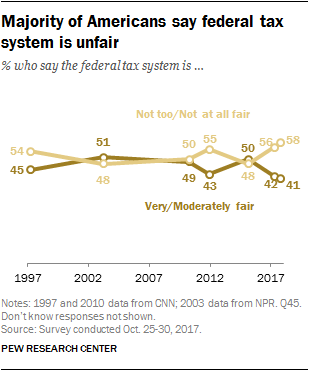Highlight a few significant elements in this photo. The largest divergent amount between the two opinions across all years is 17. In 2017, the line with a higher value is perceived as not too or not at all fair by the respondent. 